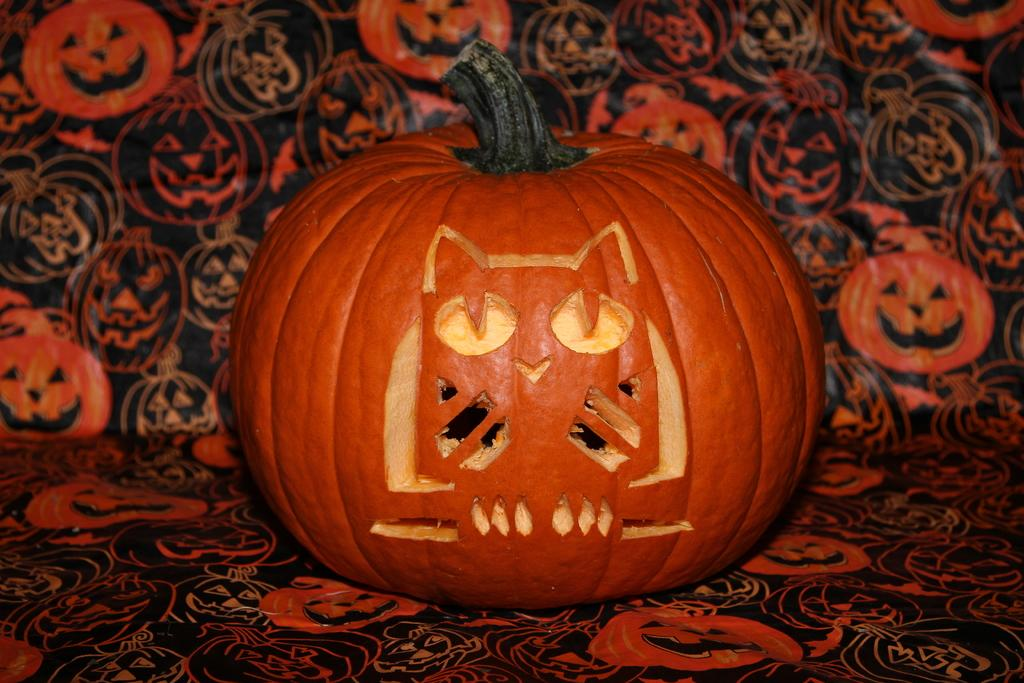What is the main object in the image? There is a pumpkin in the image. What can be seen in the background of the image? The background of the image is decorated. Can you describe the ground in the image? The ground is visible in the image. What does the pumpkin taste like in the image? The image does not provide any information about the taste of the pumpkin, as it is a visual representation and not an actual pumpkin. 